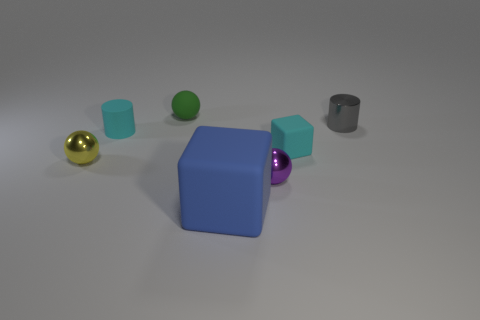There is a rubber object that is the same color as the small cube; what is its size?
Offer a terse response. Small. How many other things are the same shape as the tiny purple metallic object?
Ensure brevity in your answer.  2. Is there anything else that has the same size as the yellow metallic object?
Give a very brief answer. Yes. Is the number of yellow objects that are in front of the large thing less than the number of green matte objects?
Make the answer very short. Yes. Does the blue matte object have the same shape as the green object?
Ensure brevity in your answer.  No. What color is the small rubber object that is the same shape as the yellow metallic object?
Provide a short and direct response. Green. How many other things are the same color as the big thing?
Provide a succinct answer. 0. How many objects are rubber objects that are to the left of the tiny green sphere or small metallic balls?
Your response must be concise. 3. There is a rubber object that is behind the small gray metallic thing; what size is it?
Ensure brevity in your answer.  Small. Are there fewer small matte cubes than tiny shiny objects?
Keep it short and to the point. Yes. 